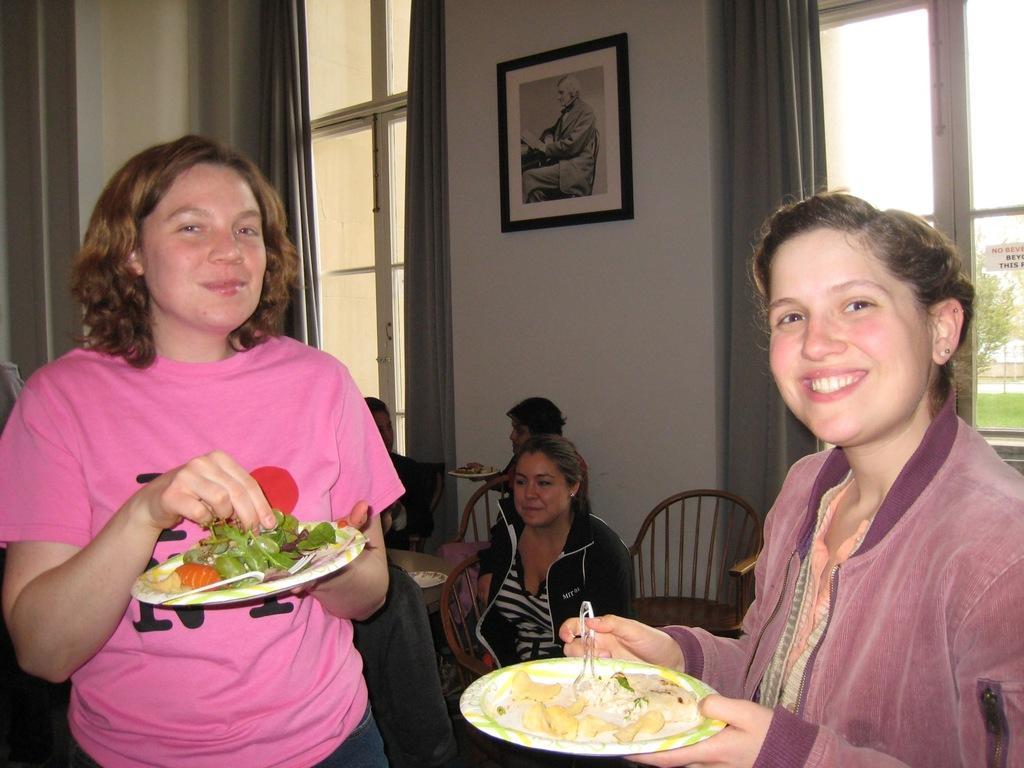Please provide a concise description of this image. In this image there are people, picture, windows, curtains, chairs, table and objects. Among them three people are holding plates and two people are standing. Picture is on the wall. Through the window I can see a tree and grass. Sticker is on the window.   